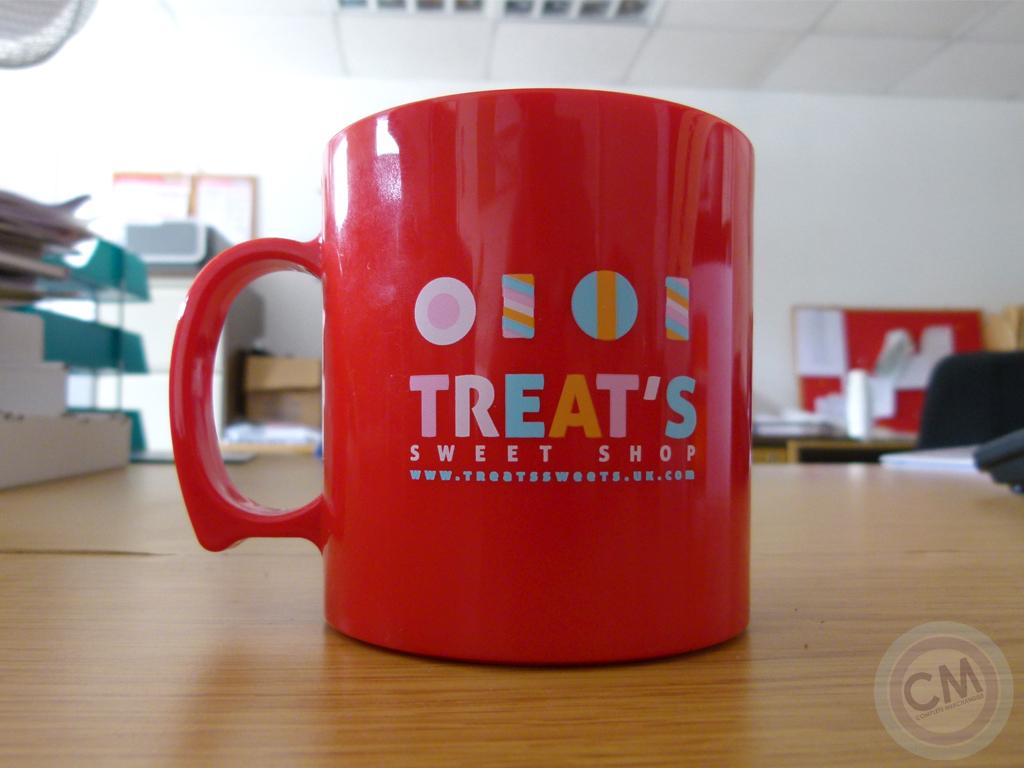What is the name of the sweet shop on the red cup?
Your response must be concise. Treat's. What is the website on the cup?
Your response must be concise. Www.treatssweets.uk.com. 